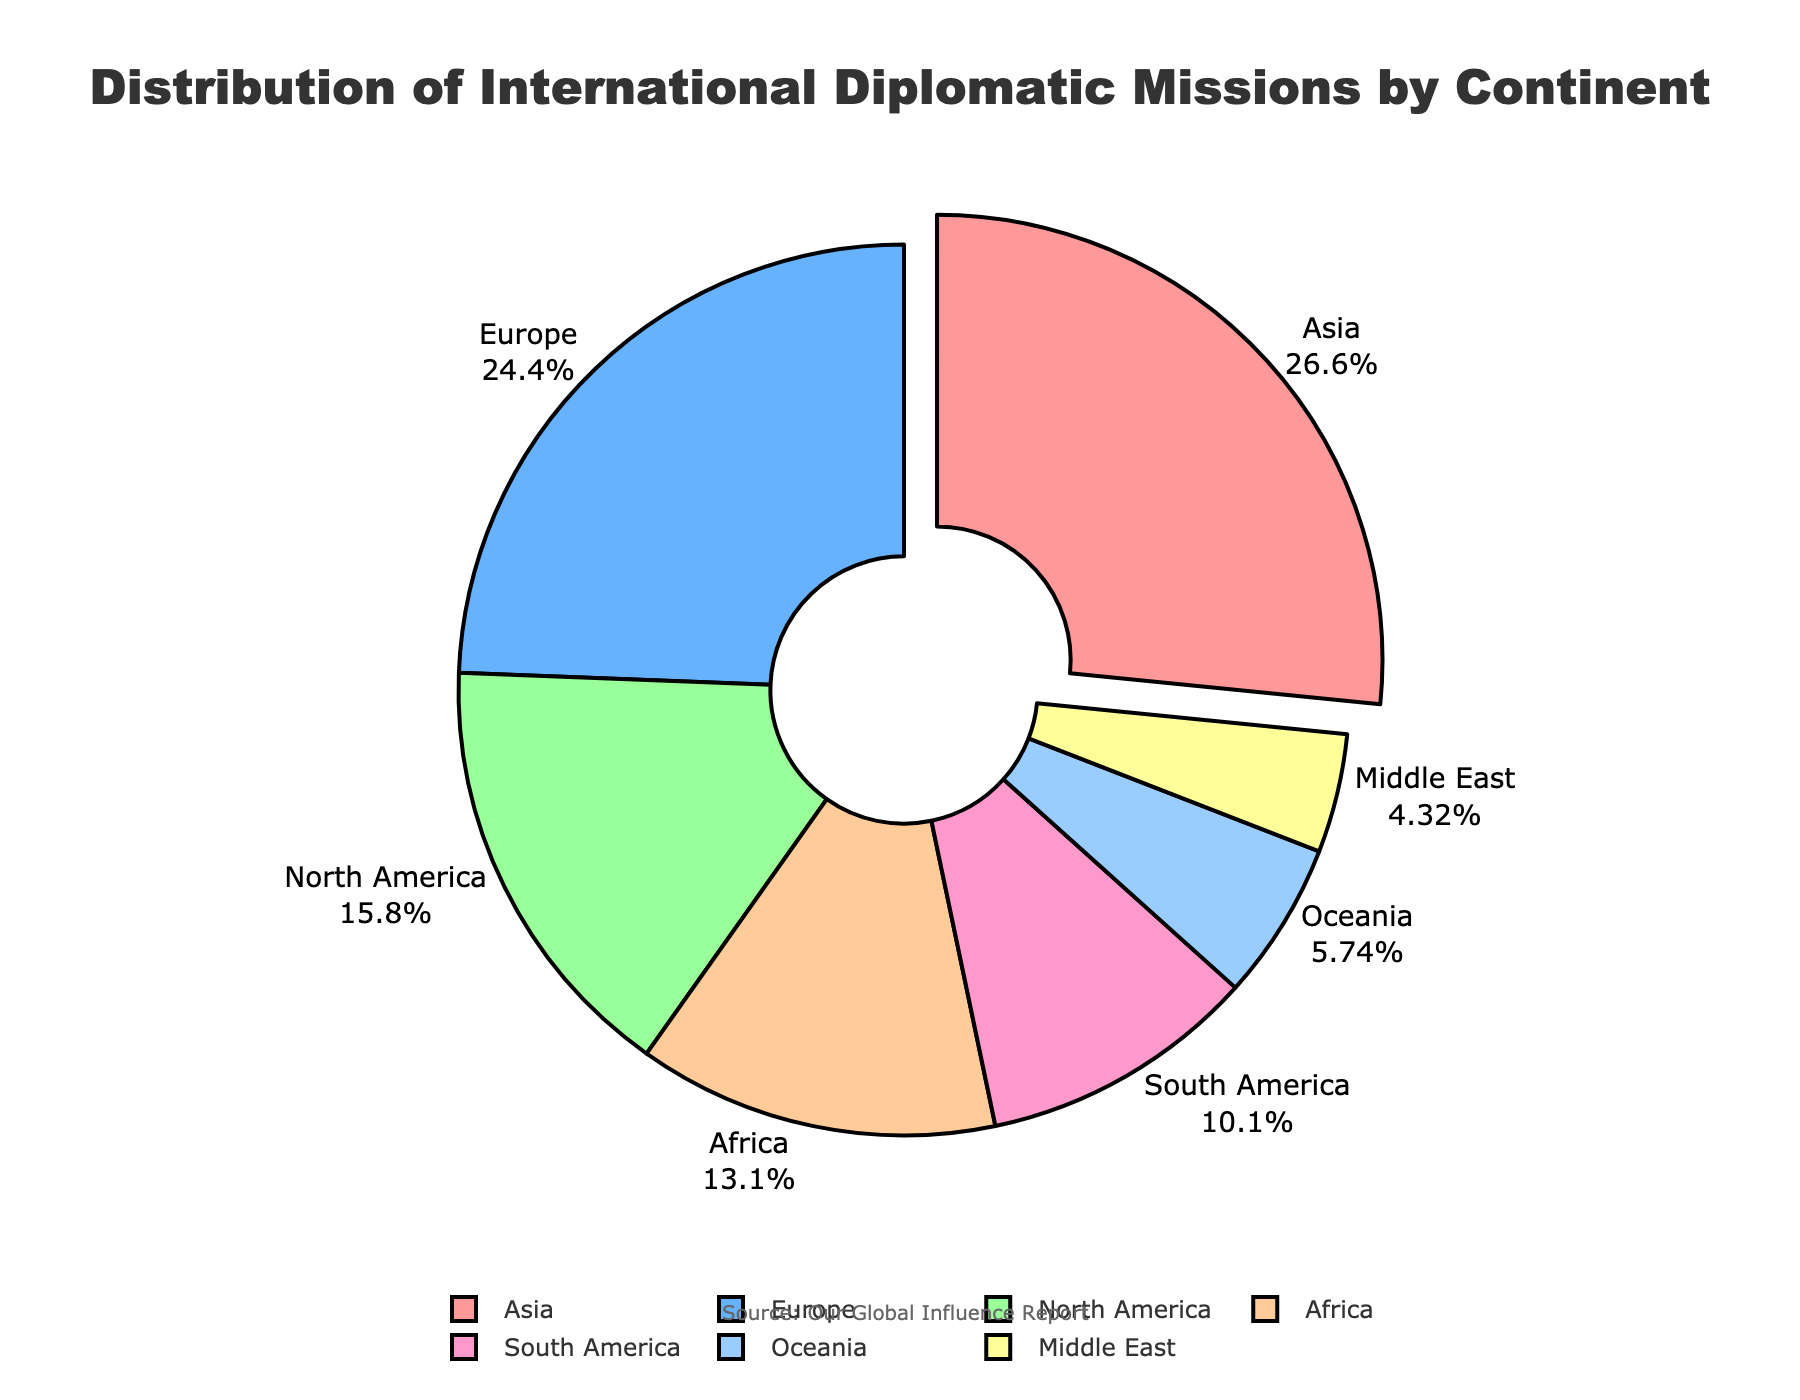What's the continent with the highest number of diplomatic missions? The largest slice in the pie chart represents the continent with the highest number of diplomatic missions, which is Asia. The label and percentage shown confirm this.
Answer: Asia Which continent has the smallest portion of diplomatic missions? The smallest slice in the pie chart represents the continent with the least number of diplomatic missions, which is the Middle East. The label and percentage confirm this.
Answer: Middle East What's the total number of diplomatic missions in Europe and Africa combined? Add the number of diplomatic missions in Europe (378) and Africa (203). So, 378 + 203 = 581.
Answer: 581 How does the number of diplomatic missions in North America compare to South America? North America has 245 diplomatic missions and South America has 156. Comparing these two numbers, North America has 89 more diplomatic missions than South America (245 - 156 = 89).
Answer: 89 more If Asia's diplomatic missions were reduced by the same amount as Oceania's total, would it still have the highest number? Asia has 412 diplomatic missions, and Oceania has 89. If Asia's missions were reduced by 89 (412 - 89 = 323), it would still have more than Europe, which has 378. So, Asia would still have the highest number.
Answer: Yes What percentage of the total diplomatic missions are in Africa? Count the total number of diplomatic missions: 412 + 378 + 245 + 203 + 156 + 89 + 67 = 1550. Africa’s portion is 203. To find the percentage: (203 / 1550) * 100 ≈ 13.1%.
Answer: 13.1% Which continents' combined diplomatic missions make up more than 50% of the total? Calculate the combined number and percentage for different groups of continents until one exceeds 50%. The total number of diplomatic missions is 1550. Asia and Europe combined: 412 + 378 = 790, (790 / 1550) * 100 ≈ 50.97%, which is more than 50%.
Answer: Asia and Europe Is the number of African diplomatic missions closer to the number in Europe or North America? Africa has 203 diplomatic missions, Europe has 378, and North America has 245. The difference with Europe is 378 - 203 = 175, and the difference with North America is 245 - 203 = 42. Africa’s number is closer to North America.
Answer: North America What is the difference between the continents with the most and least diplomatic missions? The continent with the most is Asia (412), and the one with the least is the Middle East (67). The difference is 412 - 67 = 345.
Answer: 345 